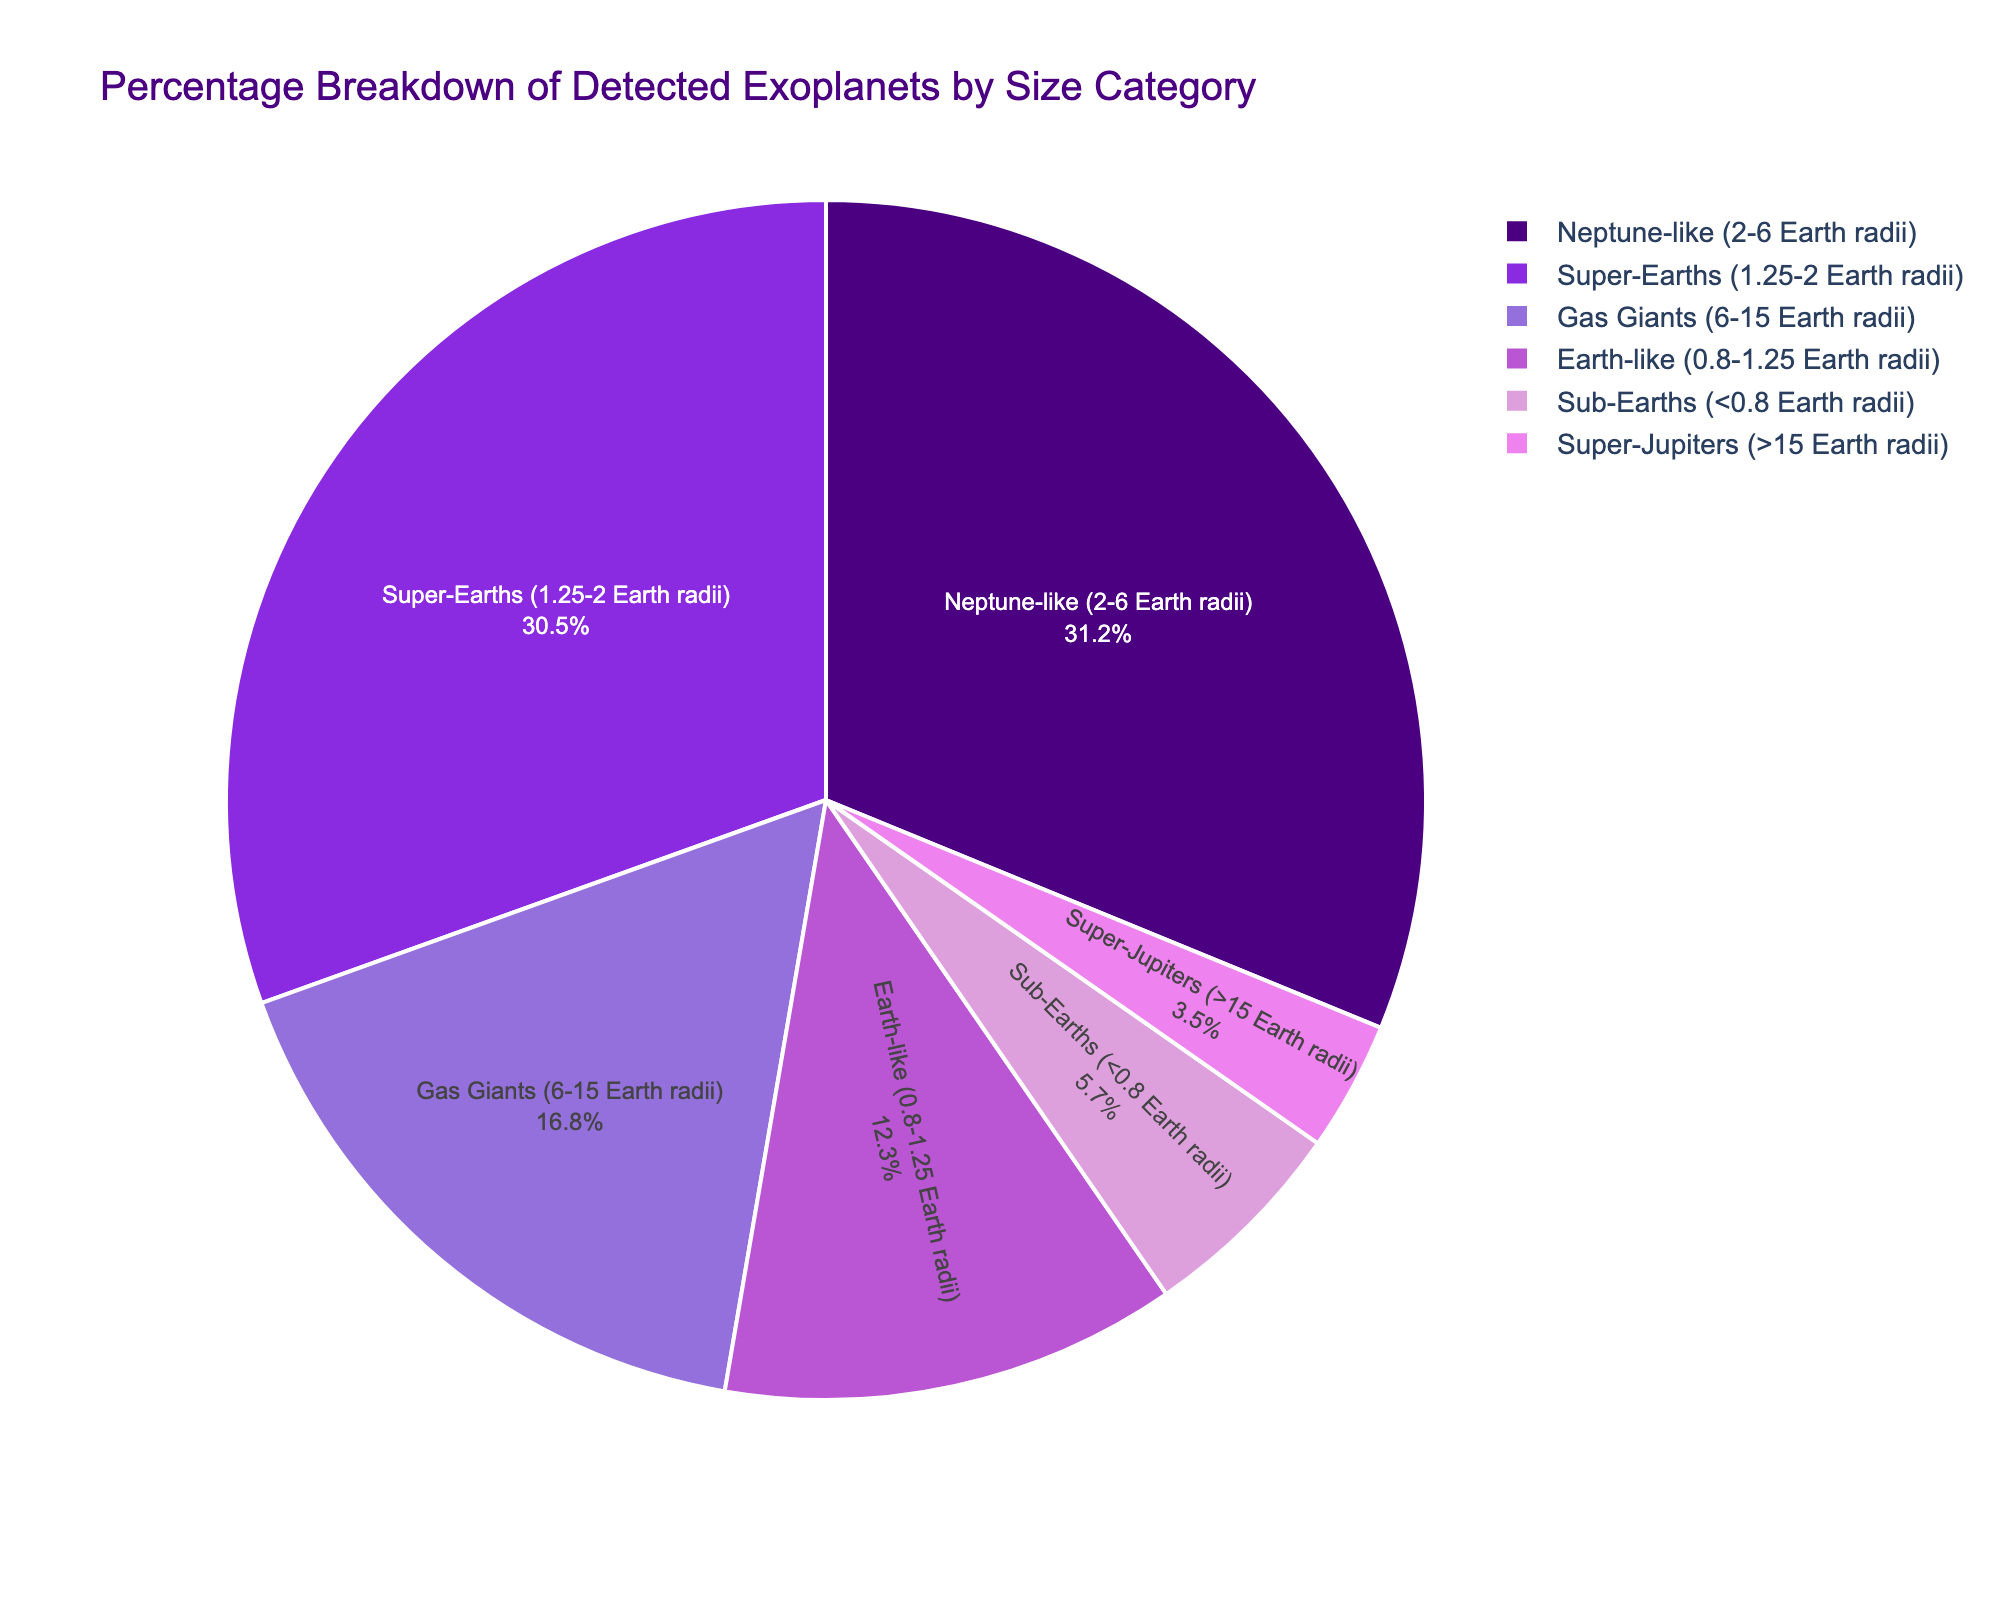What is the largest size category for detected exoplanets? The largest size category corresponds to the segment with the highest percentage. In this case, the Neptune-like category has the highest value at 31.2%.
Answer: Neptune-like (2-6 Earth radii) Which two size categories have categories percentages less than 10%? To find this, look for segments with percentages below 10%. The sub-Earths category has 5.7% and the Super-Jupiters category has 3.5%.
Answer: Sub-Earths and Super-Jupiters What is the total percentage of exoplanets in the Neptune-like and Super-Earths categories combined? Add the percentages of the Neptune-like (31.2%) and Super-Earths (30.5%) categories. 31.2% + 30.5% = 61.7%
Answer: 61.7% How do the percentages of Earth-like and Sub-Earths categories compare? The Earth-like category has a percentage of 12.3%, while the Sub-Earths category has 5.7%. Comparing the two, 12.3% is greater than 5.7%.
Answer: Earth-like has a higher percentage than Sub-Earths What is the difference in percentage between the Gas Giants and Super-Earths categories? Subtract the percentage of Gas Giants (16.8%) from the percentage of Super-Earths (30.5%). 30.5% - 16.8% = 13.7%
Answer: 13.7% Which size category is represented by the lightest shade of color in the pie chart? The Super-Jupiters category is the smallest segment at 3.5% and is presumed to be shown in the lightest color according to the custom palette sequence provided.
Answer: Super-Jupiters If we combine the percentages of the Earth-like, Sub-Earths, and Super-Jupiters categories, what is the sum? Add the percentages of Earth-like (12.3%), Sub-Earths (5.7%), and Super-Jupiters (3.5%). 12.3% + 5.7% + 3.5% = 21.5%
Answer: 21.5% Which size category forms approximately one-sixth of the pie chart? To determine this, one-sixth of 100% is approximately 16.7%. The Gas Giants category has a percentage of 16.8%, close to this fraction.
Answer: Gas Giants What percentage more Neptune-like exoplanets are there compared to Gas Giants? Subtract the percentage of Gas Giants (16.8%) from Neptune-like (31.2%) to find the percentage difference. 31.2% - 16.8% = 14.4%
Answer: 14.4% 